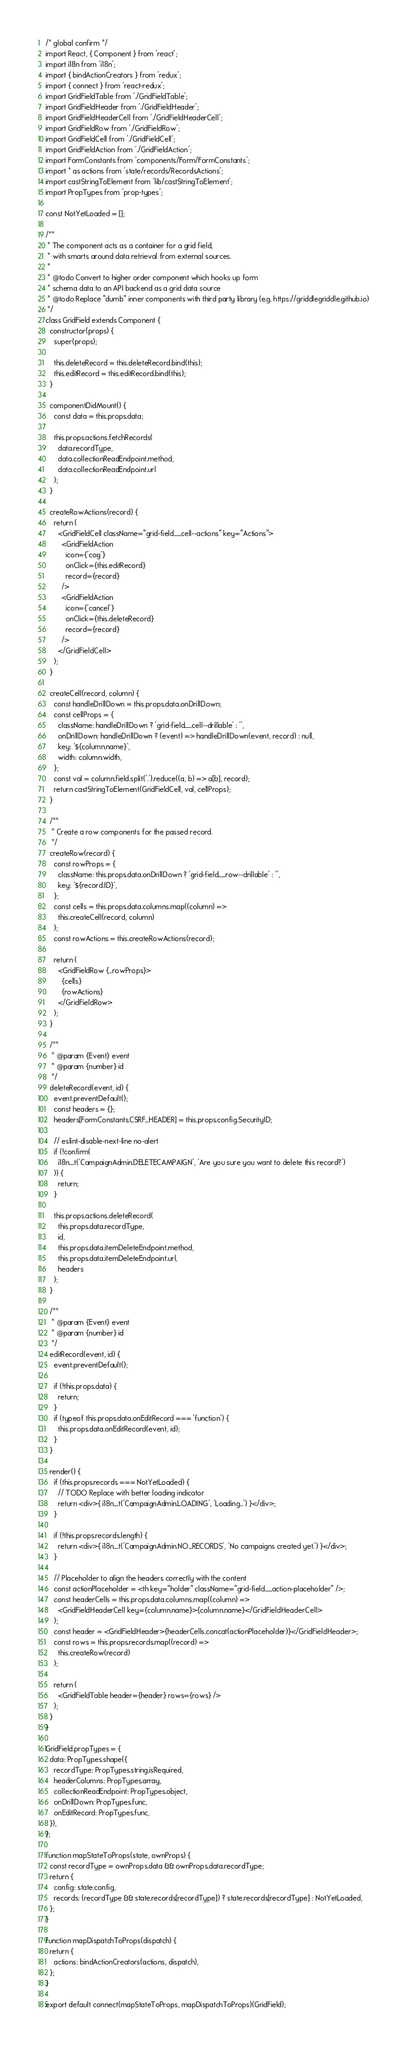<code> <loc_0><loc_0><loc_500><loc_500><_JavaScript_>/* global confirm */
import React, { Component } from 'react';
import i18n from 'i18n';
import { bindActionCreators } from 'redux';
import { connect } from 'react-redux';
import GridFieldTable from './GridFieldTable';
import GridFieldHeader from './GridFieldHeader';
import GridFieldHeaderCell from './GridFieldHeaderCell';
import GridFieldRow from './GridFieldRow';
import GridFieldCell from './GridFieldCell';
import GridFieldAction from './GridFieldAction';
import FormConstants from 'components/Form/FormConstants';
import * as actions from 'state/records/RecordsActions';
import castStringToElement from 'lib/castStringToElement';
import PropTypes from 'prop-types';

const NotYetLoaded = [];

/**
 * The component acts as a container for a grid field,
 * with smarts around data retrieval from external sources.
 *
 * @todo Convert to higher order component which hooks up form
 * schema data to an API backend as a grid data source
 * @todo Replace "dumb" inner components with third party library (e.g. https://griddlegriddle.github.io)
 */
class GridField extends Component {
  constructor(props) {
    super(props);

    this.deleteRecord = this.deleteRecord.bind(this);
    this.editRecord = this.editRecord.bind(this);
  }

  componentDidMount() {
    const data = this.props.data;

    this.props.actions.fetchRecords(
      data.recordType,
      data.collectionReadEndpoint.method,
      data.collectionReadEndpoint.url
    );
  }

  createRowActions(record) {
    return (
      <GridFieldCell className="grid-field__cell--actions" key="Actions">
        <GridFieldAction
          icon={'cog'}
          onClick={this.editRecord}
          record={record}
        />
        <GridFieldAction
          icon={'cancel'}
          onClick={this.deleteRecord}
          record={record}
        />
      </GridFieldCell>
    );
  }

  createCell(record, column) {
    const handleDrillDown = this.props.data.onDrillDown;
    const cellProps = {
      className: handleDrillDown ? 'grid-field__cell--drillable' : '',
      onDrillDown: handleDrillDown ? (event) => handleDrillDown(event, record) : null,
      key: `${column.name}`,
      width: column.width,
    };
    const val = column.field.split('.').reduce((a, b) => a[b], record);
    return castStringToElement(GridFieldCell, val, cellProps);
  }

  /**
   * Create a row components for the passed record.
   */
  createRow(record) {
    const rowProps = {
      className: this.props.data.onDrillDown ? 'grid-field__row--drillable' : '',
      key: `${record.ID}`,
    };
    const cells = this.props.data.columns.map((column) =>
      this.createCell(record, column)
    );
    const rowActions = this.createRowActions(record);

    return (
      <GridFieldRow {...rowProps}>
        {cells}
        {rowActions}
      </GridFieldRow>
    );
  }

  /**
   * @param {Event} event
   * @param {number} id
   */
  deleteRecord(event, id) {
    event.preventDefault();
    const headers = {};
    headers[FormConstants.CSRF_HEADER] = this.props.config.SecurityID;

    // eslint-disable-next-line no-alert
    if (!confirm(
      i18n._t('CampaignAdmin.DELETECAMPAIGN', 'Are you sure you want to delete this record?')
    )) {
      return;
    }

    this.props.actions.deleteRecord(
      this.props.data.recordType,
      id,
      this.props.data.itemDeleteEndpoint.method,
      this.props.data.itemDeleteEndpoint.url,
      headers
    );
  }

  /**
   * @param {Event} event
   * @param {number} id
   */
  editRecord(event, id) {
    event.preventDefault();

    if (!this.props.data) {
      return;
    }
    if (typeof this.props.data.onEditRecord === 'function') {
      this.props.data.onEditRecord(event, id);
    }
  }

  render() {
    if (this.props.records === NotYetLoaded) {
      // TODO Replace with better loading indicator
      return <div>{ i18n._t('CampaignAdmin.LOADING', 'Loading...') }</div>;
    }

    if (!this.props.records.length) {
      return <div>{ i18n._t('CampaignAdmin.NO_RECORDS', 'No campaigns created yet.') }</div>;
    }

    // Placeholder to align the headers correctly with the content
    const actionPlaceholder = <th key="holder" className="grid-field__action-placeholder" />;
    const headerCells = this.props.data.columns.map((column) =>
      <GridFieldHeaderCell key={column.name}>{column.name}</GridFieldHeaderCell>
    );
    const header = <GridFieldHeader>{headerCells.concat(actionPlaceholder)}</GridFieldHeader>;
    const rows = this.props.records.map((record) =>
      this.createRow(record)
    );

    return (
      <GridFieldTable header={header} rows={rows} />
    );
  }
}

GridField.propTypes = {
  data: PropTypes.shape({
    recordType: PropTypes.string.isRequired,
    headerColumns: PropTypes.array,
    collectionReadEndpoint: PropTypes.object,
    onDrillDown: PropTypes.func,
    onEditRecord: PropTypes.func,
  }),
};

function mapStateToProps(state, ownProps) {
  const recordType = ownProps.data && ownProps.data.recordType;
  return {
    config: state.config,
    records: (recordType && state.records[recordType]) ? state.records[recordType] : NotYetLoaded,
  };
}

function mapDispatchToProps(dispatch) {
  return {
    actions: bindActionCreators(actions, dispatch),
  };
}

export default connect(mapStateToProps, mapDispatchToProps)(GridField);
</code> 